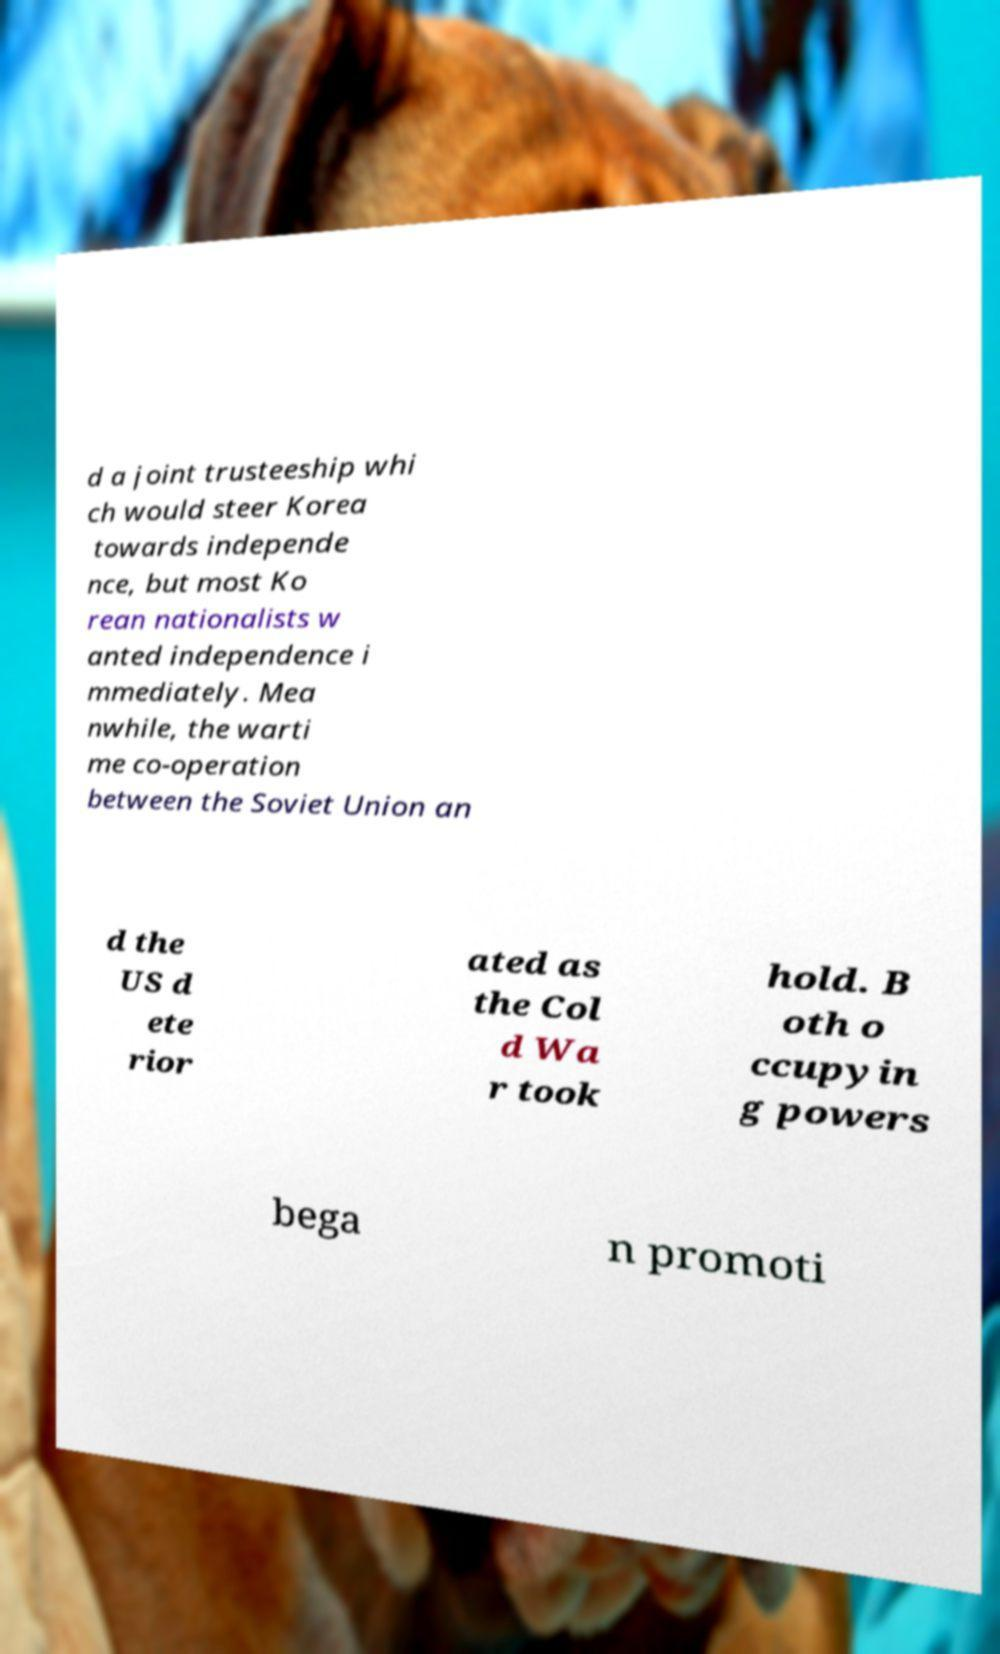Can you read and provide the text displayed in the image?This photo seems to have some interesting text. Can you extract and type it out for me? d a joint trusteeship whi ch would steer Korea towards independe nce, but most Ko rean nationalists w anted independence i mmediately. Mea nwhile, the warti me co-operation between the Soviet Union an d the US d ete rior ated as the Col d Wa r took hold. B oth o ccupyin g powers bega n promoti 